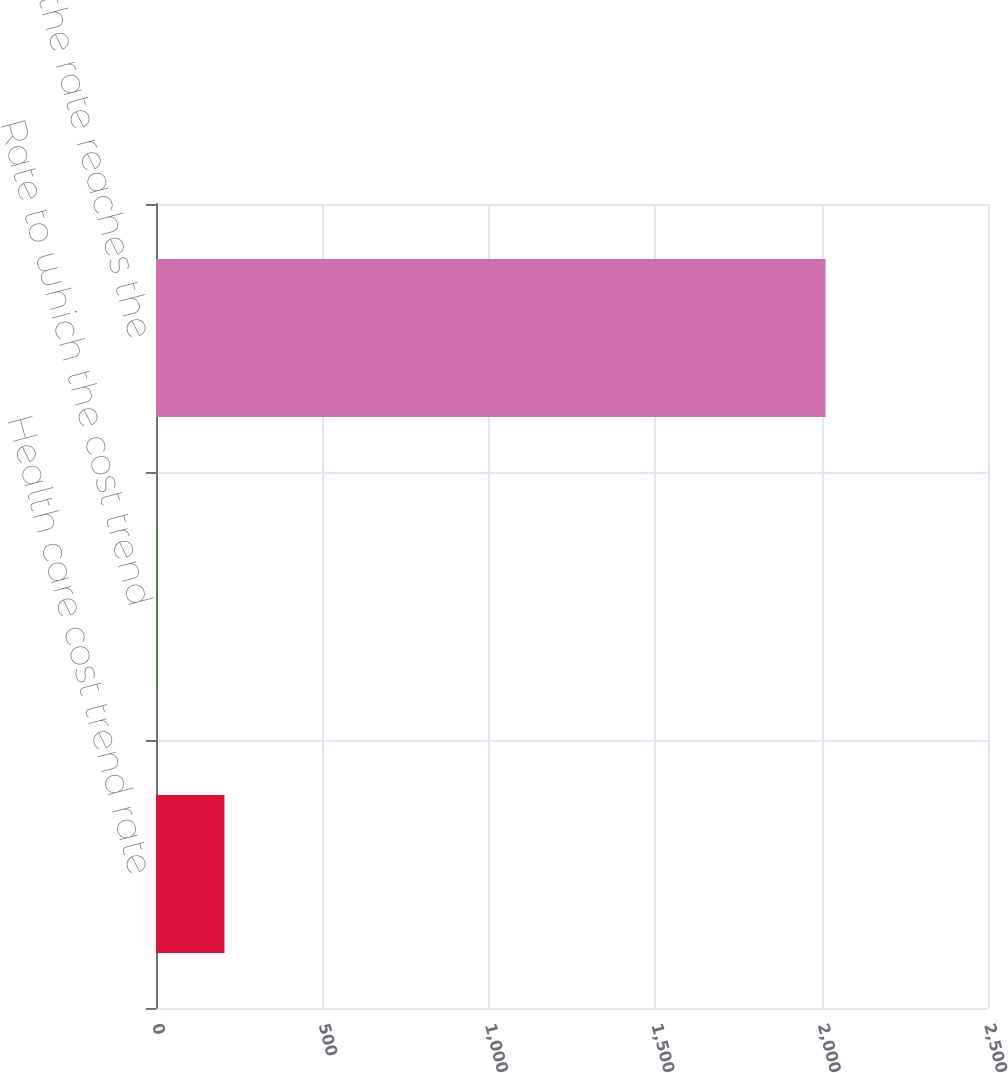<chart> <loc_0><loc_0><loc_500><loc_500><bar_chart><fcel>Health care cost trend rate<fcel>Rate to which the cost trend<fcel>Year that the rate reaches the<nl><fcel>205.7<fcel>5<fcel>2012<nl></chart> 